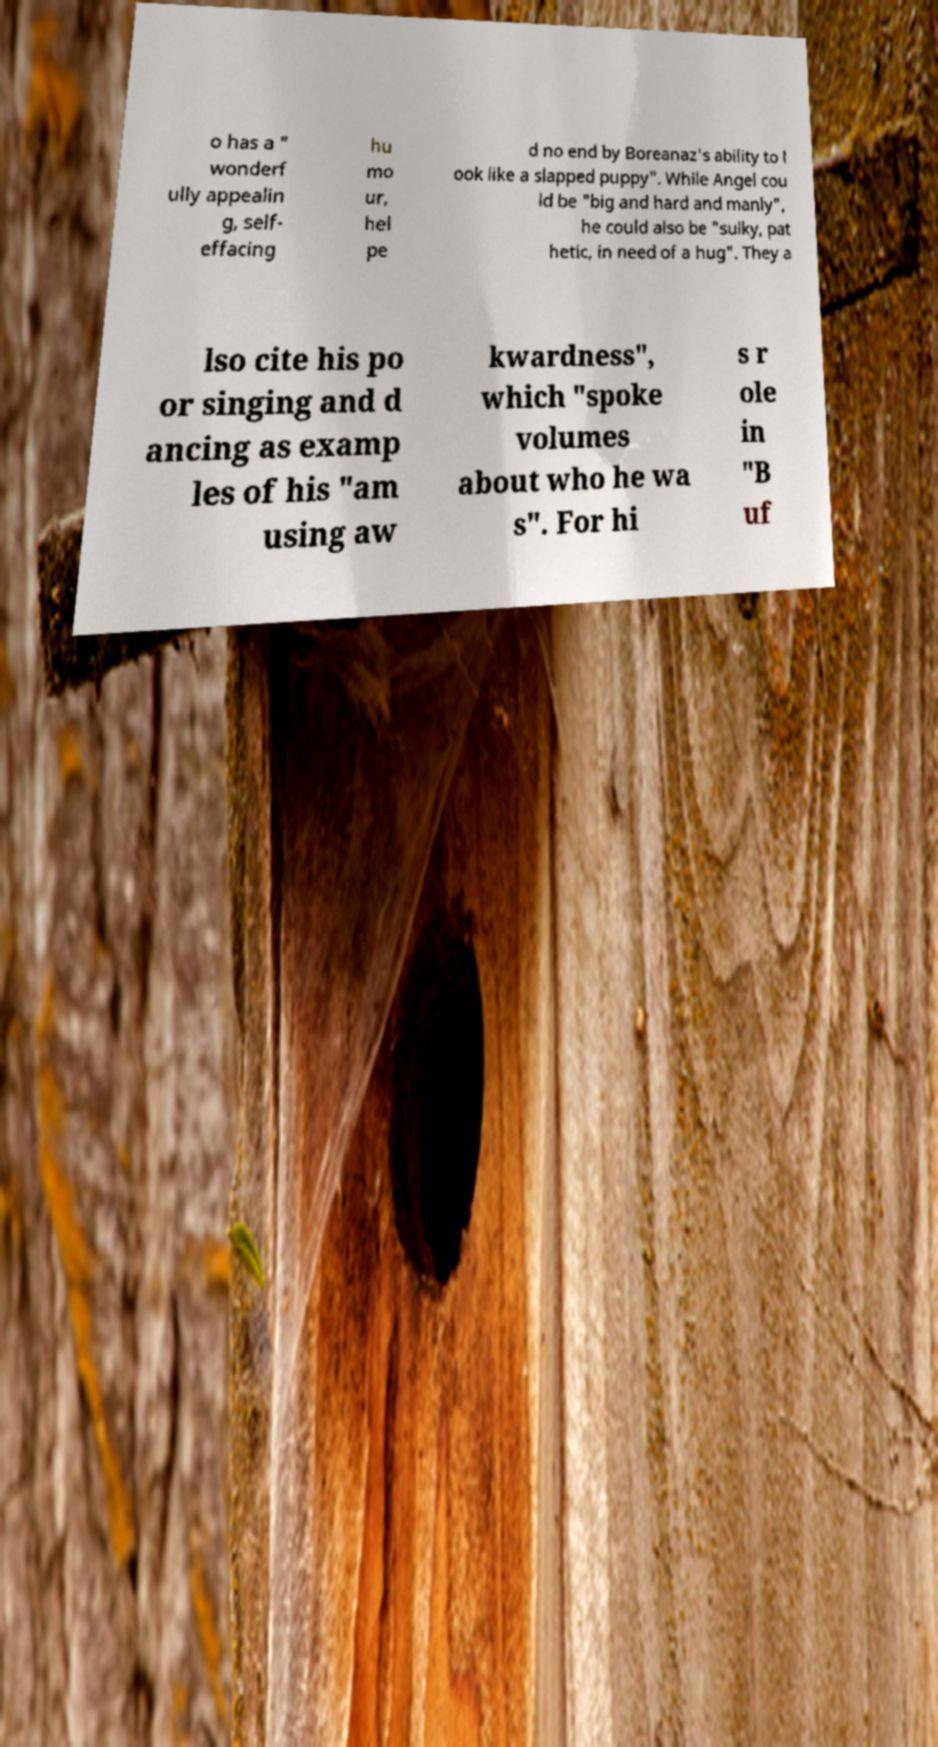For documentation purposes, I need the text within this image transcribed. Could you provide that? o has a " wonderf ully appealin g, self- effacing hu mo ur, hel pe d no end by Boreanaz's ability to l ook like a slapped puppy". While Angel cou ld be "big and hard and manly", he could also be "sulky, pat hetic, in need of a hug". They a lso cite his po or singing and d ancing as examp les of his "am using aw kwardness", which "spoke volumes about who he wa s". For hi s r ole in "B uf 